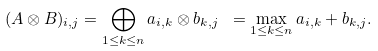<formula> <loc_0><loc_0><loc_500><loc_500>( A \otimes B ) _ { i , j } = \bigoplus _ { 1 \leq k \leq n } a _ { i , k } \otimes b _ { k , j } \ = \max _ { 1 \leq k \leq n } a _ { i , k } + b _ { k , j } .</formula> 